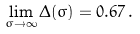<formula> <loc_0><loc_0><loc_500><loc_500>\lim _ { \sigma \to \infty } \Delta ( \sigma ) = 0 . 6 7 \, .</formula> 